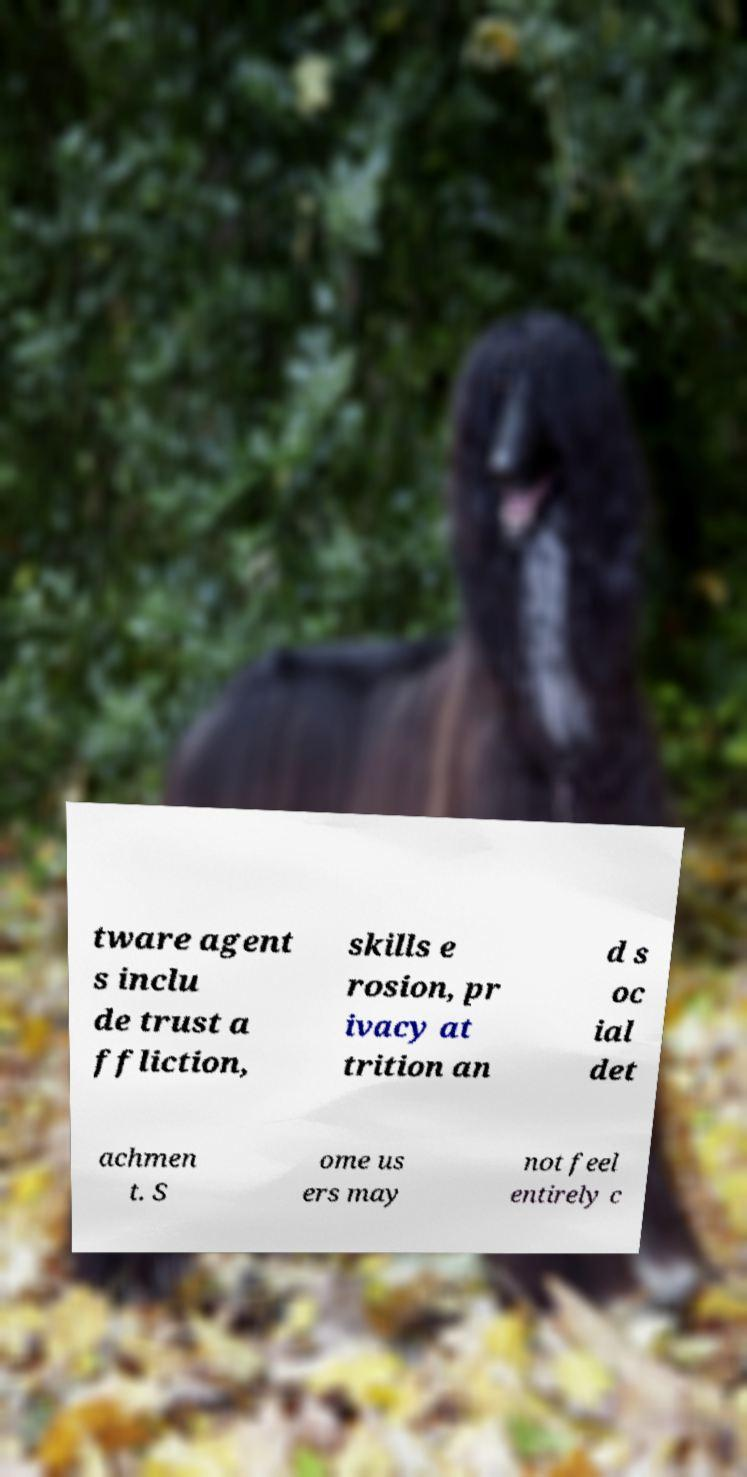There's text embedded in this image that I need extracted. Can you transcribe it verbatim? tware agent s inclu de trust a ffliction, skills e rosion, pr ivacy at trition an d s oc ial det achmen t. S ome us ers may not feel entirely c 